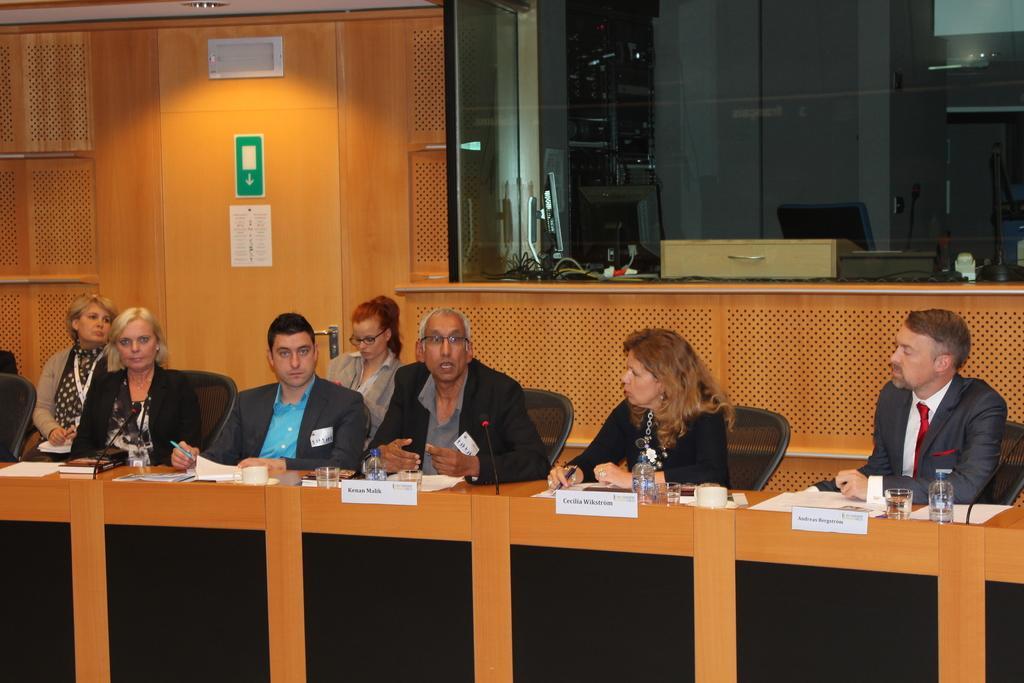Can you describe this image briefly? In this image there are a few people sitting around the table, on the table there are few papers, glasses, name boards, bottles, there we can see a computer, cables and some other objects through the glass door, there are posters to the wall. 